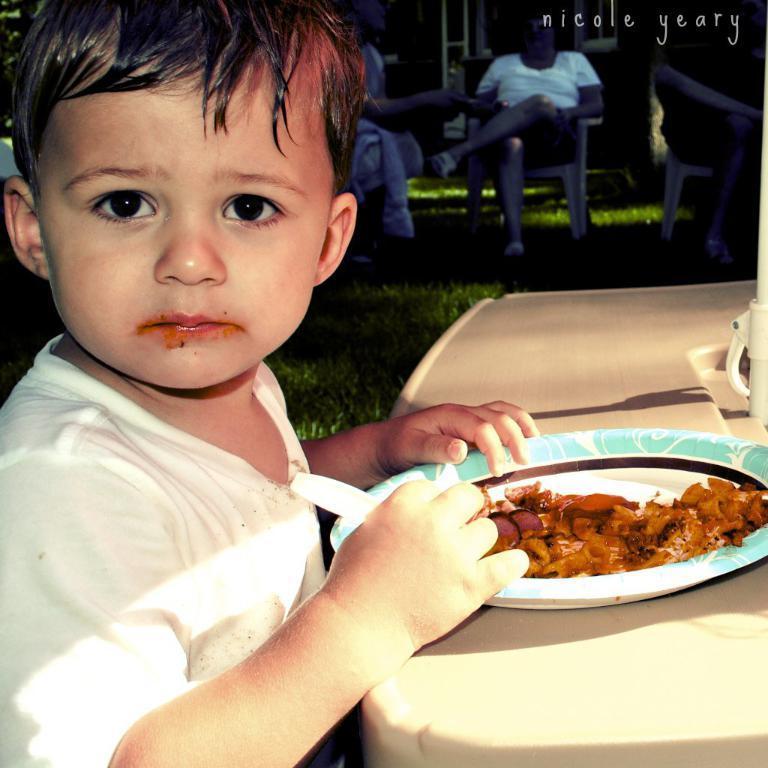Describe this image in one or two sentences. In this image we can see a group of people sitting on chairs. One boy is holding a spoon in his hand. On the right side of the image we can see food placed in a plate kept on the table, we can also see a pole. In the center of the image we can see the grass. At the top of the image we can see building, trees and some text. 